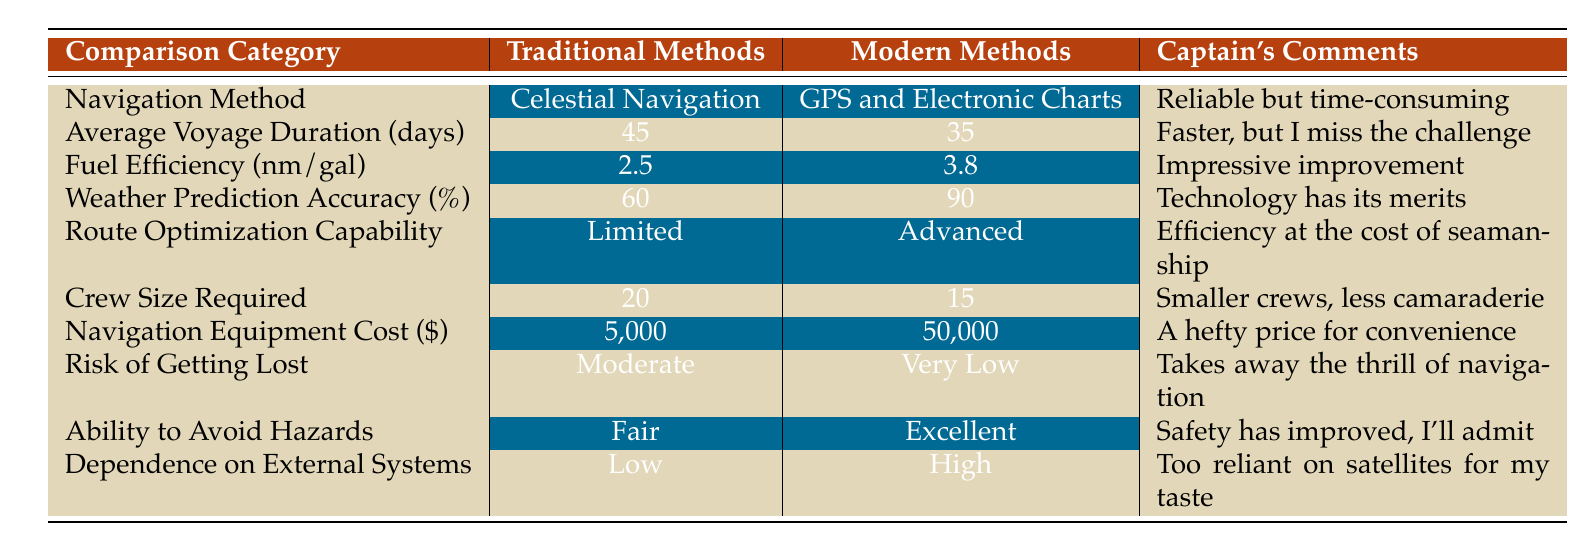What is the average voyage duration using traditional navigation methods? The table states that the average voyage duration for traditional methods is 45 days.
Answer: 45 days Which navigation method offers a higher fuel efficiency? The table shows that traditional methods have a fuel efficiency of 2.5 nautical miles per gallon, while modern methods have 3.8 nautical miles per gallon, indicating that modern methods are more efficient.
Answer: Modern methods What is the difference in weather prediction accuracy between traditional and modern methods? Traditional methods have a weather prediction accuracy of 60%, while modern methods have 90%. The difference is calculated as 90% - 60% = 30%.
Answer: 30% Is there a lower risk of getting lost when using modern navigation methods compared to traditional ones? The table indicates that the risk of getting lost for traditional methods is "Moderate" while for modern methods it is "Very Low," confirming a lower risk with modern methods.
Answer: Yes What is the average crew size required for traditional navigation methods compared to modern methods? The crew size required for traditional navigation methods is 20, while for modern methods it is 15. To find the average, we add them (20 + 15) = 35 and divide by 2, resulting in an average crew size of 17.5.
Answer: 17.5 How much more does the navigation equipment cost for modern methods compared to traditional methods? The cost for traditional navigation equipment is $5,000, while for modern methods it is $50,000. The difference is calculated as $50,000 - $5,000 = $45,000.
Answer: $45,000 Are traditional navigation methods more dependent on external systems than modern ones? According to the table, traditional methods have a dependence on external systems classified as "Low," whereas modern methods are classified as "High," which indicates that modern methods are more dependent.
Answer: No Which method has the capability for route optimization? The table states that traditional methods have "Limited" route optimization capability, while modern methods have "Advanced" capability. Thus, modern methods are superior in this aspect.
Answer: Modern methods Does traditional navigation provide a higher ability to avoid hazards compared to modern navigation? The table reveals that traditional methods have a "Fair" ability to avoid hazards, whereas modern methods have an "Excellent" ability indicating that traditional methods do not provide a higher capability.
Answer: No 